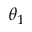<formula> <loc_0><loc_0><loc_500><loc_500>\theta _ { 1 }</formula> 